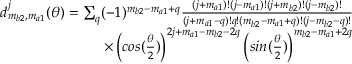Convert formula to latex. <formula><loc_0><loc_0><loc_500><loc_500>\begin{array} { r } { d _ { m _ { b 2 } , m _ { a 1 } } ^ { j } ( \theta ) = \sum _ { q } ( - 1 ) ^ { m _ { b 2 } - m _ { a 1 } + q } \frac { ( j + m _ { a 1 } ) ! ( j - m _ { a 1 } ) ! ( j + m _ { b 2 } ) ! ( j - m _ { b 2 } ) ! } { ( j + m _ { a 1 } - q ) ! q ! ( m _ { b 2 } - m _ { a 1 } + q ) ! ( j - m _ { b 2 } - q ) ! } } \\ { \times \left ( \cos ( \frac { \theta } { 2 } ) \right ) ^ { 2 j + m _ { a 1 } - m _ { b 2 } - 2 q } \left ( \sin ( \frac { \theta } { 2 } ) \right ) ^ { m _ { b 2 } - m _ { a 1 } + 2 q } } \end{array}</formula> 